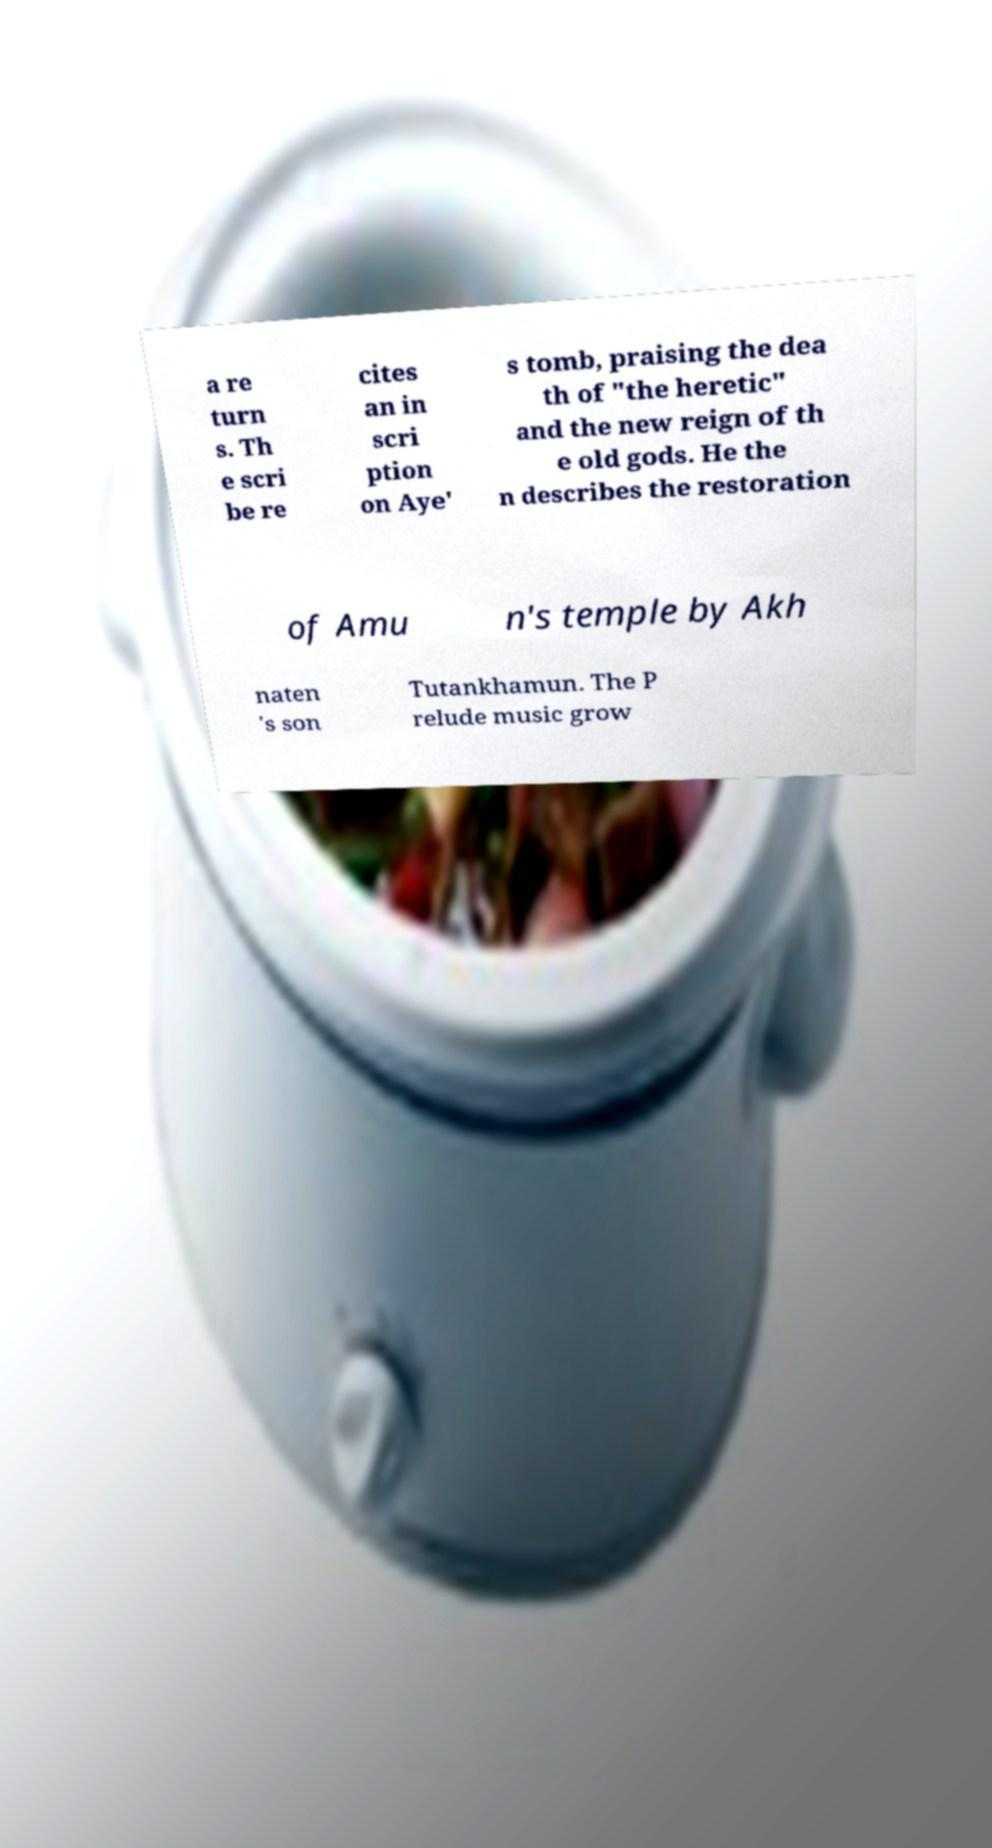What messages or text are displayed in this image? I need them in a readable, typed format. a re turn s. Th e scri be re cites an in scri ption on Aye' s tomb, praising the dea th of "the heretic" and the new reign of th e old gods. He the n describes the restoration of Amu n's temple by Akh naten 's son Tutankhamun. The P relude music grow 